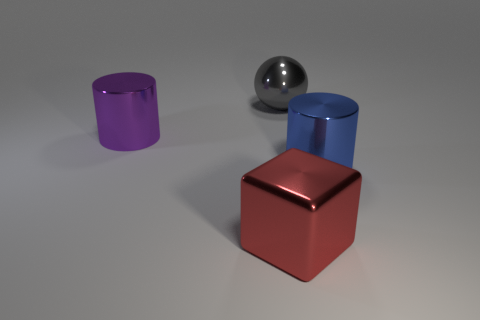There is a metallic thing that is behind the big purple metal object; is its shape the same as the purple object?
Your response must be concise. No. Is the shape of the red thing the same as the purple thing?
Offer a terse response. No. How many shiny objects are cylinders or tiny balls?
Ensure brevity in your answer.  2. Does the gray metal ball have the same size as the red block?
Your answer should be compact. Yes. How many objects are either tiny red cylinders or big things that are in front of the gray shiny thing?
Your answer should be very brief. 3. There is a cube that is the same size as the blue cylinder; what is its material?
Your answer should be compact. Metal. What material is the thing that is in front of the purple object and on the right side of the red shiny cube?
Offer a very short reply. Metal. Are there any large gray metallic objects behind the big cylinder on the right side of the big gray ball?
Your response must be concise. Yes. What is the size of the thing that is in front of the metallic ball and right of the cube?
Give a very brief answer. Large. What number of red objects are either large rubber cylinders or big things?
Give a very brief answer. 1. 